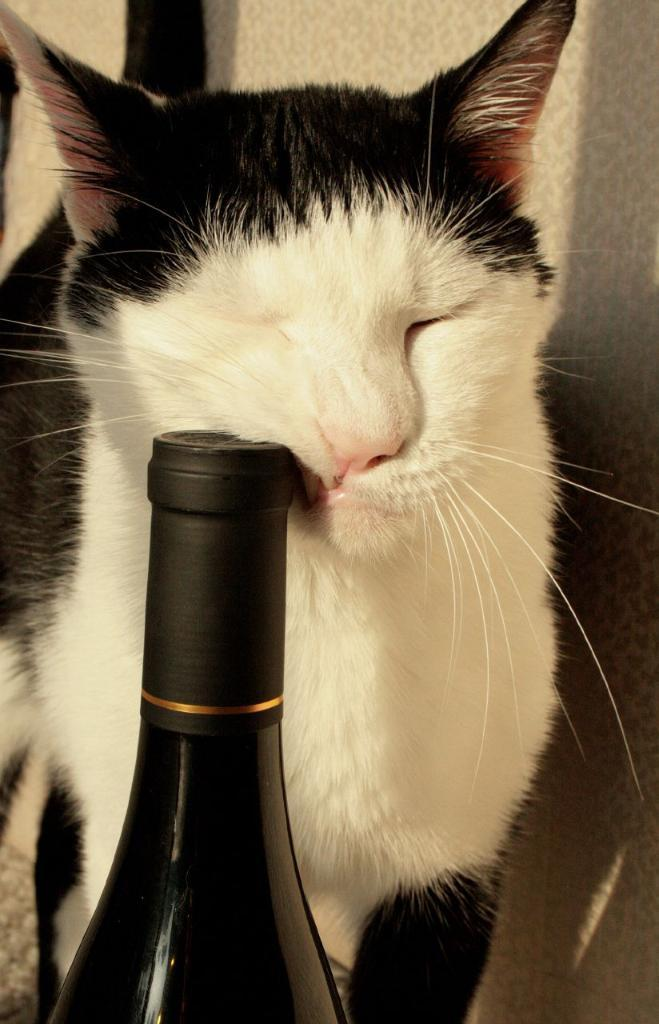What type of animal is in the image? There is a black and white cat in the image. What object can be seen at the bottom of the image? There is a bottle at the bottom of the image. How many appliances are being used by the giants in the image? There are no giants or appliances present in the image. What type of bird can be seen with the turkey in the image? There is no bird or turkey present in the image. 